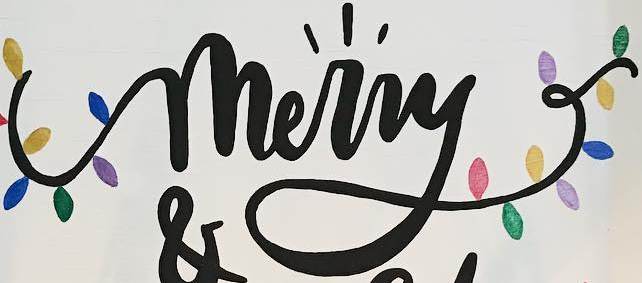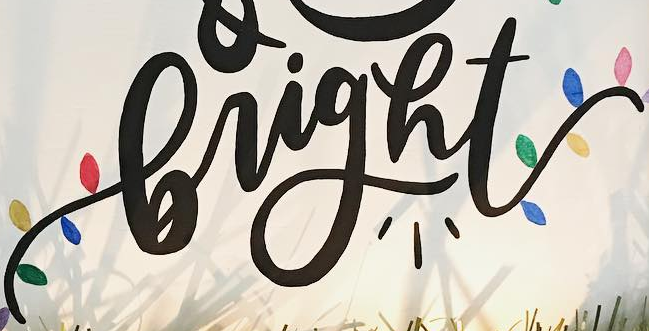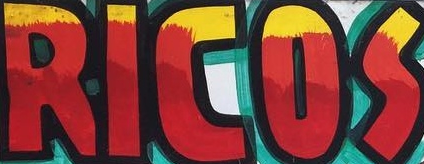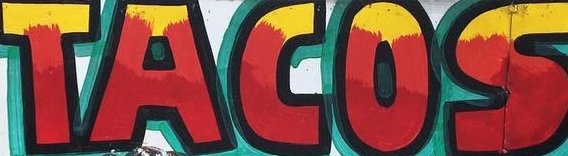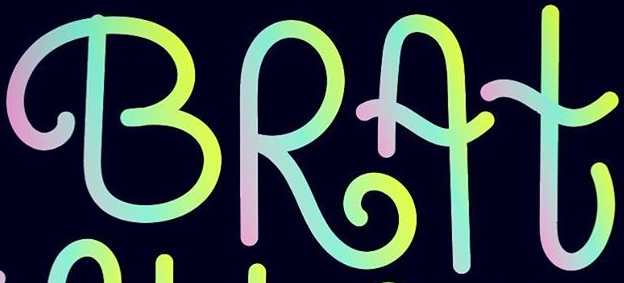What words are shown in these images in order, separated by a semicolon? merry; bright; RICOS; TACOS; BRAt 